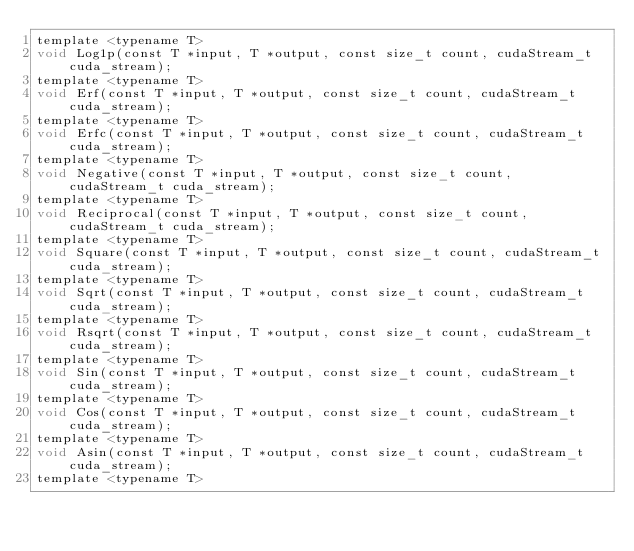Convert code to text. <code><loc_0><loc_0><loc_500><loc_500><_Cuda_>template <typename T>
void Log1p(const T *input, T *output, const size_t count, cudaStream_t cuda_stream);
template <typename T>
void Erf(const T *input, T *output, const size_t count, cudaStream_t cuda_stream);
template <typename T>
void Erfc(const T *input, T *output, const size_t count, cudaStream_t cuda_stream);
template <typename T>
void Negative(const T *input, T *output, const size_t count, cudaStream_t cuda_stream);
template <typename T>
void Reciprocal(const T *input, T *output, const size_t count, cudaStream_t cuda_stream);
template <typename T>
void Square(const T *input, T *output, const size_t count, cudaStream_t cuda_stream);
template <typename T>
void Sqrt(const T *input, T *output, const size_t count, cudaStream_t cuda_stream);
template <typename T>
void Rsqrt(const T *input, T *output, const size_t count, cudaStream_t cuda_stream);
template <typename T>
void Sin(const T *input, T *output, const size_t count, cudaStream_t cuda_stream);
template <typename T>
void Cos(const T *input, T *output, const size_t count, cudaStream_t cuda_stream);
template <typename T>
void Asin(const T *input, T *output, const size_t count, cudaStream_t cuda_stream);
template <typename T></code> 